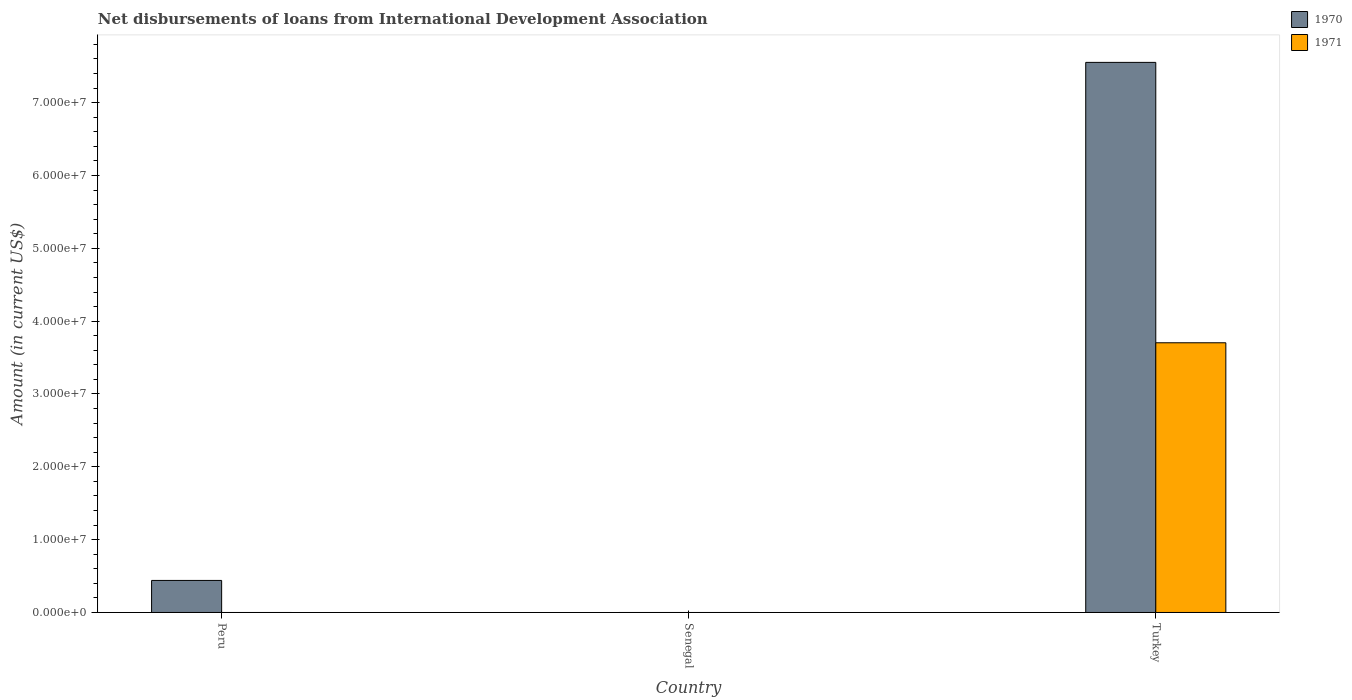How many different coloured bars are there?
Your answer should be compact. 2. Are the number of bars per tick equal to the number of legend labels?
Give a very brief answer. No. Are the number of bars on each tick of the X-axis equal?
Your response must be concise. No. How many bars are there on the 1st tick from the right?
Keep it short and to the point. 2. What is the label of the 3rd group of bars from the left?
Provide a succinct answer. Turkey. Across all countries, what is the maximum amount of loans disbursed in 1971?
Your answer should be very brief. 3.70e+07. Across all countries, what is the minimum amount of loans disbursed in 1971?
Provide a succinct answer. 0. In which country was the amount of loans disbursed in 1971 maximum?
Give a very brief answer. Turkey. What is the total amount of loans disbursed in 1971 in the graph?
Your answer should be very brief. 3.70e+07. What is the difference between the amount of loans disbursed in 1970 in Peru and that in Turkey?
Offer a very short reply. -7.11e+07. What is the difference between the amount of loans disbursed in 1970 in Senegal and the amount of loans disbursed in 1971 in Peru?
Offer a very short reply. 0. What is the average amount of loans disbursed in 1970 per country?
Offer a very short reply. 2.66e+07. What is the difference between the amount of loans disbursed of/in 1970 and amount of loans disbursed of/in 1971 in Turkey?
Give a very brief answer. 3.85e+07. In how many countries, is the amount of loans disbursed in 1971 greater than 50000000 US$?
Give a very brief answer. 0. What is the difference between the highest and the lowest amount of loans disbursed in 1970?
Offer a terse response. 7.55e+07. In how many countries, is the amount of loans disbursed in 1970 greater than the average amount of loans disbursed in 1970 taken over all countries?
Provide a short and direct response. 1. How many bars are there?
Make the answer very short. 3. Are all the bars in the graph horizontal?
Keep it short and to the point. No. Are the values on the major ticks of Y-axis written in scientific E-notation?
Give a very brief answer. Yes. Does the graph contain grids?
Give a very brief answer. No. Where does the legend appear in the graph?
Offer a terse response. Top right. How are the legend labels stacked?
Provide a succinct answer. Vertical. What is the title of the graph?
Your answer should be compact. Net disbursements of loans from International Development Association. What is the label or title of the X-axis?
Keep it short and to the point. Country. What is the Amount (in current US$) in 1970 in Peru?
Give a very brief answer. 4.40e+06. What is the Amount (in current US$) in 1970 in Senegal?
Provide a succinct answer. 0. What is the Amount (in current US$) in 1971 in Senegal?
Keep it short and to the point. 0. What is the Amount (in current US$) in 1970 in Turkey?
Your response must be concise. 7.55e+07. What is the Amount (in current US$) of 1971 in Turkey?
Provide a succinct answer. 3.70e+07. Across all countries, what is the maximum Amount (in current US$) in 1970?
Your answer should be compact. 7.55e+07. Across all countries, what is the maximum Amount (in current US$) in 1971?
Make the answer very short. 3.70e+07. Across all countries, what is the minimum Amount (in current US$) of 1970?
Ensure brevity in your answer.  0. Across all countries, what is the minimum Amount (in current US$) of 1971?
Offer a terse response. 0. What is the total Amount (in current US$) in 1970 in the graph?
Offer a terse response. 7.99e+07. What is the total Amount (in current US$) of 1971 in the graph?
Offer a very short reply. 3.70e+07. What is the difference between the Amount (in current US$) of 1970 in Peru and that in Turkey?
Keep it short and to the point. -7.11e+07. What is the difference between the Amount (in current US$) of 1970 in Peru and the Amount (in current US$) of 1971 in Turkey?
Offer a very short reply. -3.26e+07. What is the average Amount (in current US$) in 1970 per country?
Your answer should be compact. 2.66e+07. What is the average Amount (in current US$) in 1971 per country?
Your response must be concise. 1.23e+07. What is the difference between the Amount (in current US$) in 1970 and Amount (in current US$) in 1971 in Turkey?
Your answer should be compact. 3.85e+07. What is the ratio of the Amount (in current US$) in 1970 in Peru to that in Turkey?
Make the answer very short. 0.06. What is the difference between the highest and the lowest Amount (in current US$) in 1970?
Your answer should be compact. 7.55e+07. What is the difference between the highest and the lowest Amount (in current US$) in 1971?
Ensure brevity in your answer.  3.70e+07. 